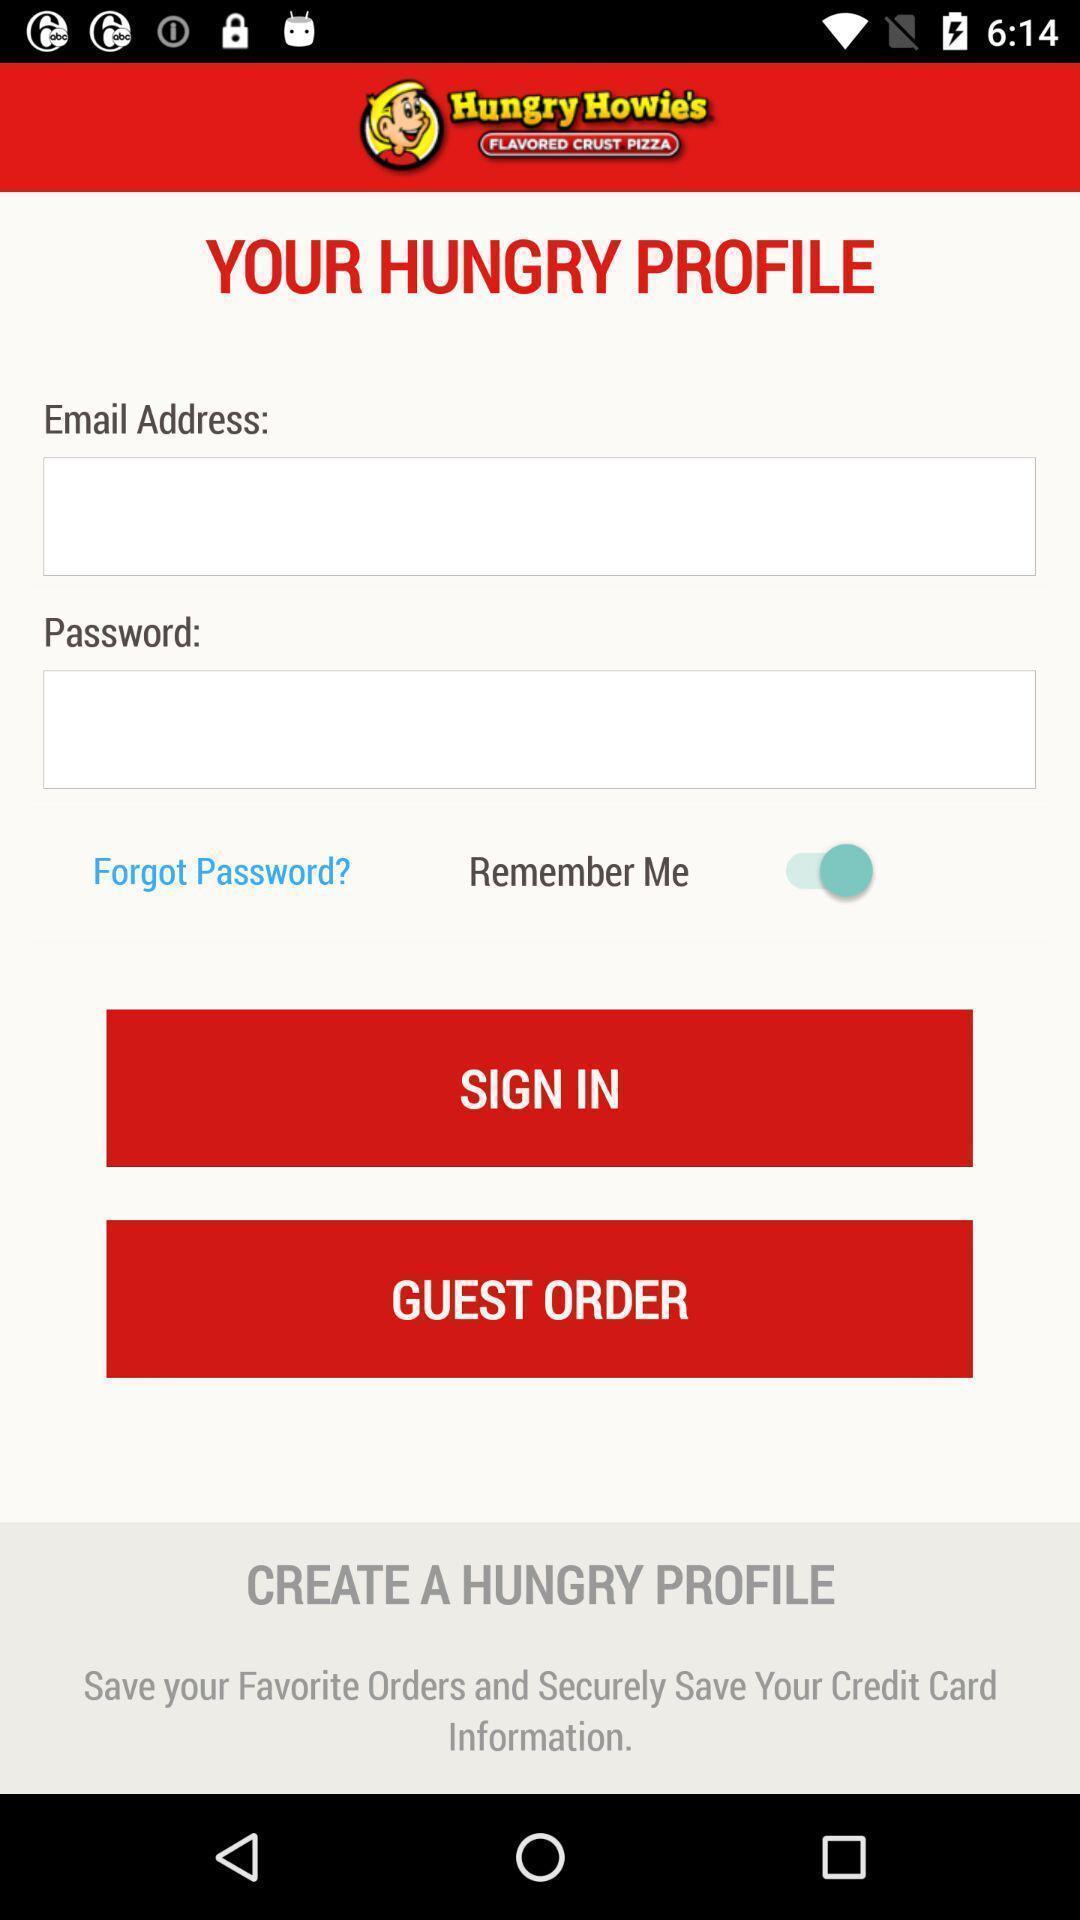Give me a summary of this screen capture. Sign in page of a food app. 